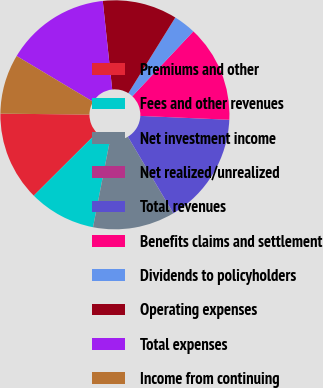Convert chart to OTSL. <chart><loc_0><loc_0><loc_500><loc_500><pie_chart><fcel>Premiums and other<fcel>Fees and other revenues<fcel>Net investment income<fcel>Net realized/unrealized<fcel>Total revenues<fcel>Benefits claims and settlement<fcel>Dividends to policyholders<fcel>Operating expenses<fcel>Total expenses<fcel>Income from continuing<nl><fcel>12.63%<fcel>9.47%<fcel>11.58%<fcel>0.01%<fcel>15.78%<fcel>13.68%<fcel>3.17%<fcel>10.53%<fcel>14.73%<fcel>8.42%<nl></chart> 